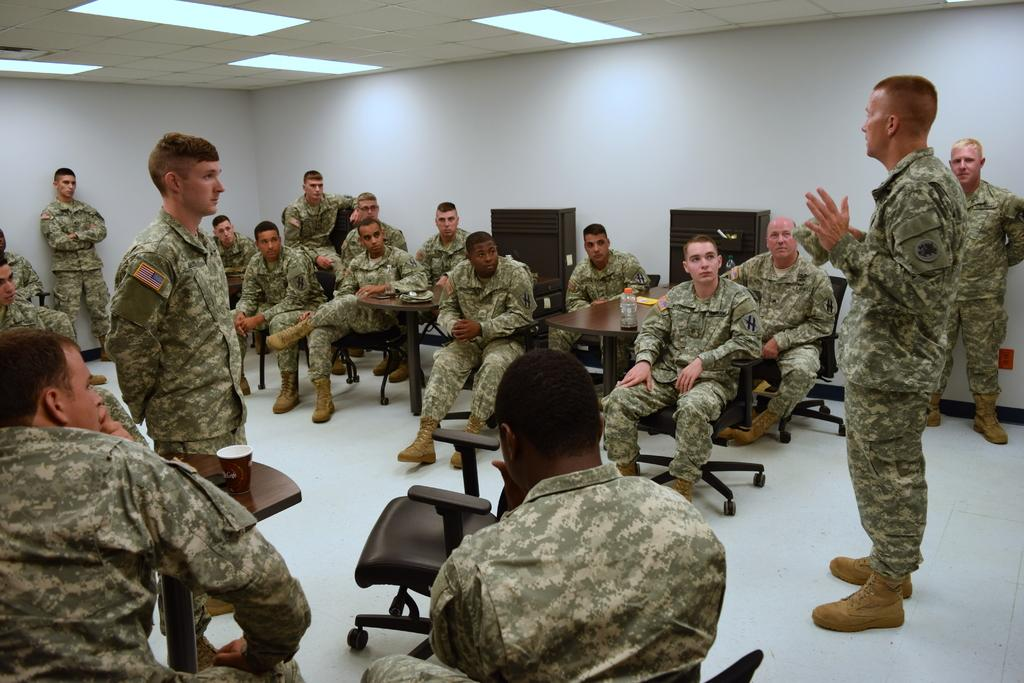What are the people in the image doing? There are people sitting on chairs and standing in the image. What can be seen in the background of the image? There is a wall, a cabinet, and the ceiling visible in the background of the image. What type of skate is being used by the people in the image? There is no skate present in the image; the people are either sitting on chairs or standing. Can you tell me the color of the vase on the cabinet in the image? There is no vase present on the cabinet in the image. 